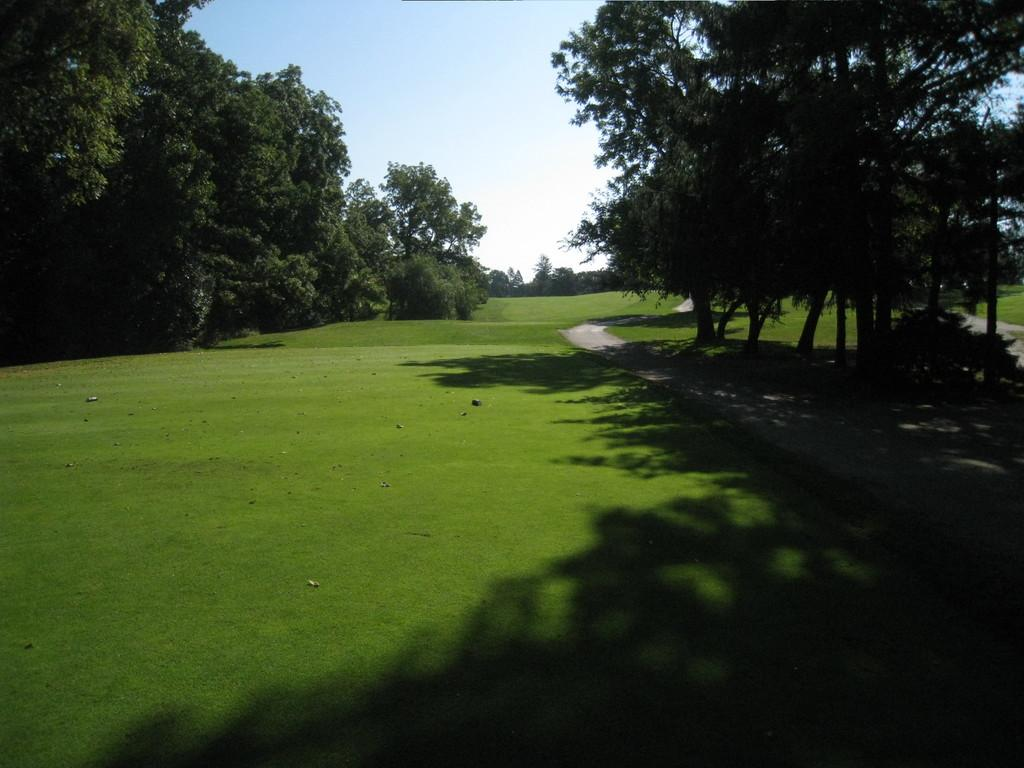What type of landscape is in the center of the image? There is a grassland in the center of the image. What can be seen on the right side of the image? There are trees and a way on the right side of the image. What is present on the left side of the image? There are trees on the left side of the image. What type of breakfast is being served to the friends in the image? There are no friends or breakfast present in the image; it features a grassland and trees. 